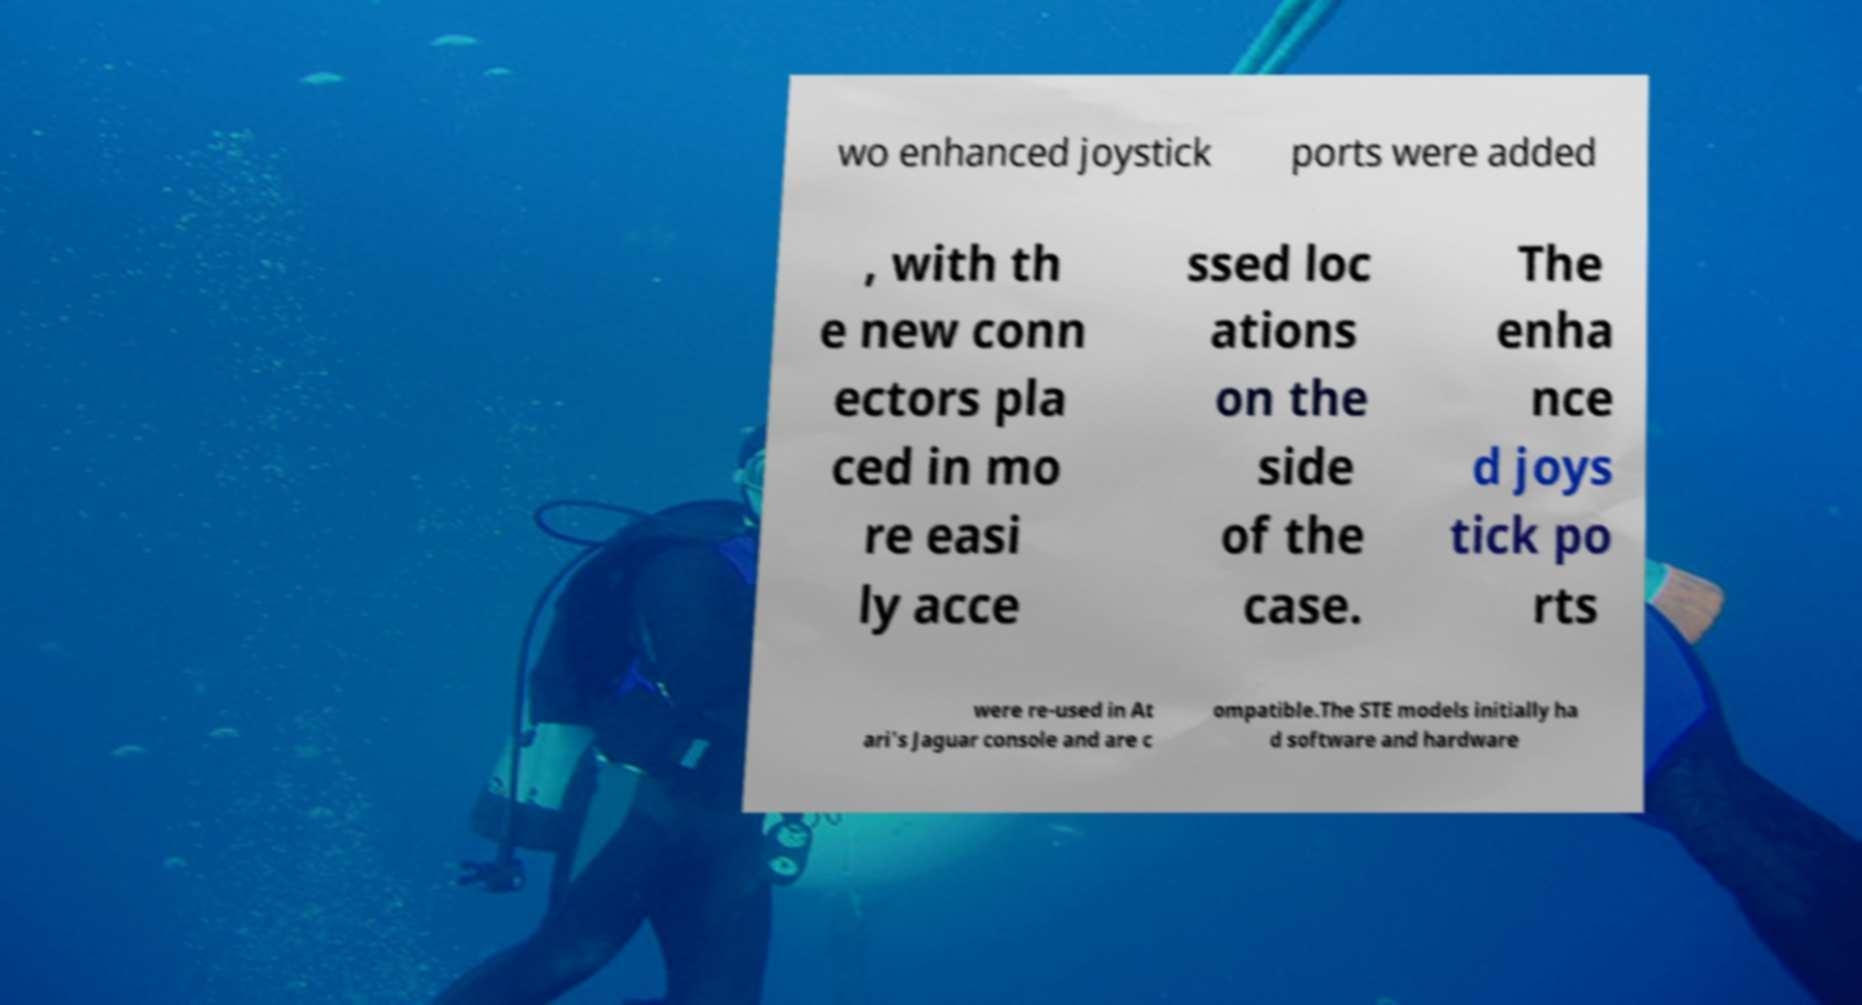Please read and relay the text visible in this image. What does it say? wo enhanced joystick ports were added , with th e new conn ectors pla ced in mo re easi ly acce ssed loc ations on the side of the case. The enha nce d joys tick po rts were re-used in At ari's Jaguar console and are c ompatible.The STE models initially ha d software and hardware 